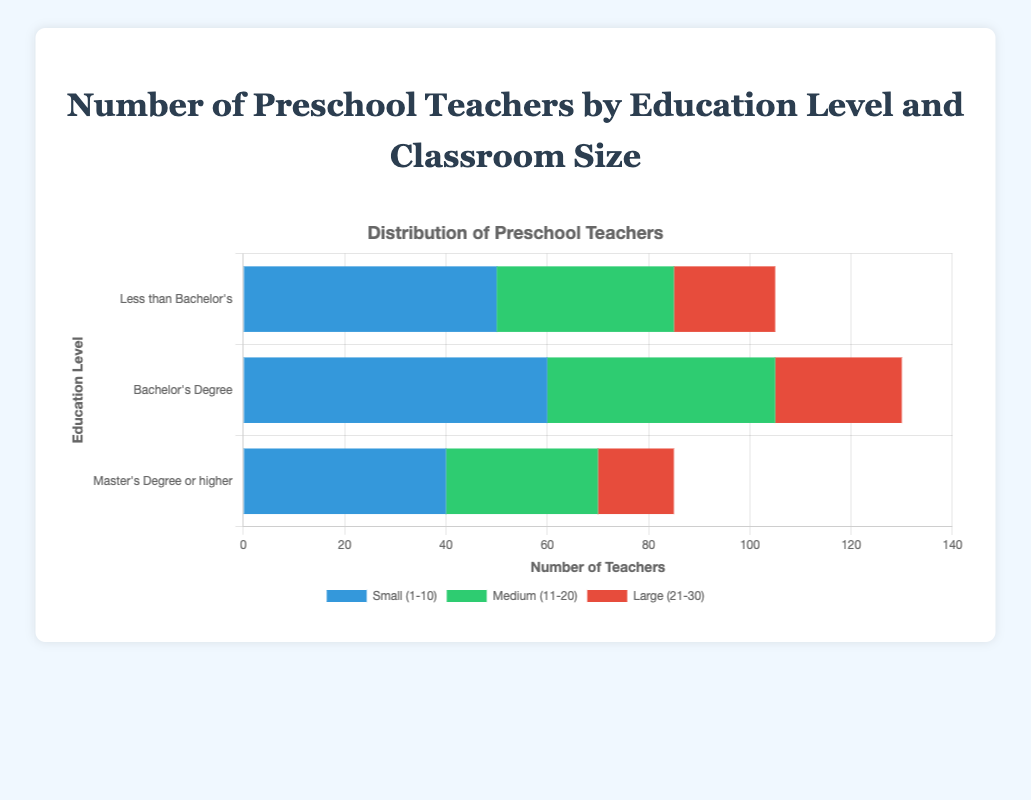Which education level has the highest number of teachers for small classrooms (1-10)? Look at the bars for "Small (1-10)" and compare their heights across the education levels. The bar for "Bachelor's Degree" is the tallest.
Answer: Bachelor's Degree Which classroom size category has the least number of teachers with "Master's Degree or higher" education? Identify the bars corresponding to "Master's Degree or higher" and compare their heights. The smallest bar is for "Large (21-30)".
Answer: Large (21-30) What is the total number of teachers with "Less than Bachelor's" education across all classroom sizes? Sum the values for "Less than Bachelor's" across the small, medium, and large classroom sizes: 50 + 35 + 20.
Answer: 105 How does the number of teachers with "Bachelor's Degree" in large classrooms (21-30) compare to those with "Less than Bachelor's" in the same classroom size? For large classrooms, compare the bar heights of "Bachelor's Degree" (25) and "Less than Bachelor's" (20). 25 is greater than 20.
Answer: More for Bachelor's Degree What is the difference between the number of teachers with a "Master's Degree or higher" in small classrooms and medium classrooms? Subtract the number of teachers in medium classrooms from small classrooms for "Master's Degree or higher" education: 40 - 30.
Answer: 10 Which classroom size has the most balanced distribution of teachers across all education levels? Compare the heights of bars for all education levels within each classroom size. Medium classrooms have bars of similar heights.
Answer: Medium (11-20) What is the combined total of teachers in small (1-10) classrooms across all education levels? Add the values for small classrooms: 50 (Less than Bachelor's) + 60 (Bachelor's Degree) + 40 (Master's Degree or higher).
Answer: 150 Is there a classroom size category where the number of teachers decreases as the education level increases? Examine the trends for each classroom size. In large classrooms (21-30), the number of teachers decreases as the education level increases.
Answer: Yes, in large (21-30) What's the difference between the total number of teachers in medium (11-20) classrooms and the total number in large (21-30) classrooms across all education levels? Sum the values for medium and large classrooms: 35+45+30 for medium, and 20+25+15 for large. Calculate the difference: (35+45+30) - (20+25+15).
Answer: 130 - 60, so 70 Which classroom size has the highest number of teachers with a "Bachelor's Degree"? Among the bars labeled "Bachelor's Degree," the tallest corresponds to small classrooms (1-10).
Answer: Small (1-10) 